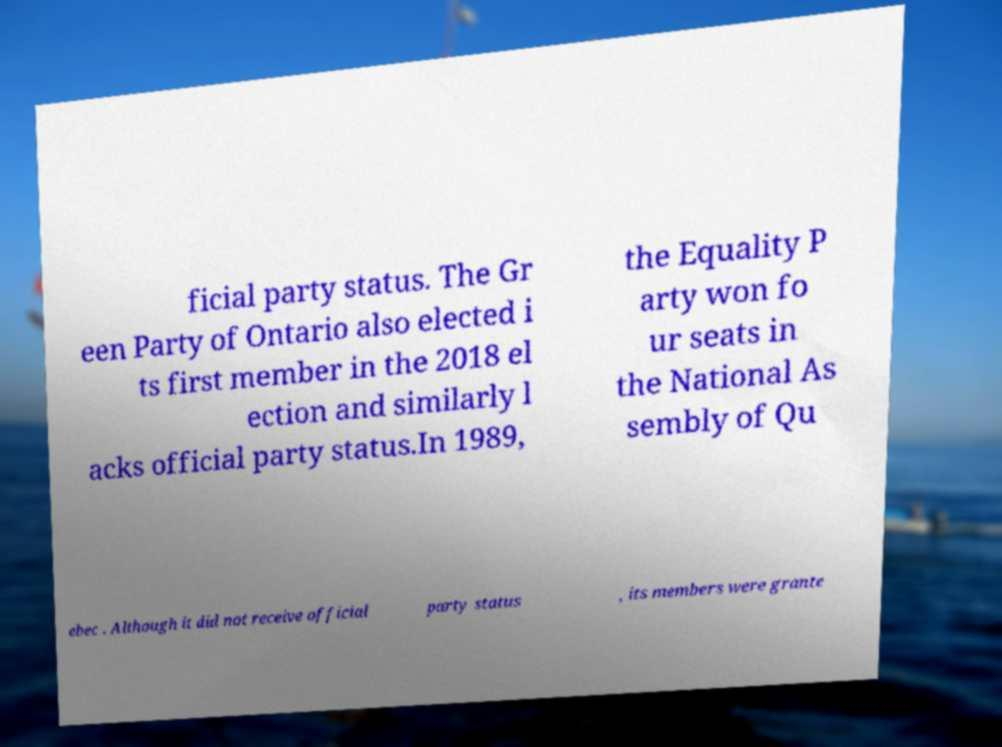There's text embedded in this image that I need extracted. Can you transcribe it verbatim? ficial party status. The Gr een Party of Ontario also elected i ts first member in the 2018 el ection and similarly l acks official party status.In 1989, the Equality P arty won fo ur seats in the National As sembly of Qu ebec . Although it did not receive official party status , its members were grante 